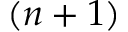Convert formula to latex. <formula><loc_0><loc_0><loc_500><loc_500>( n + 1 )</formula> 